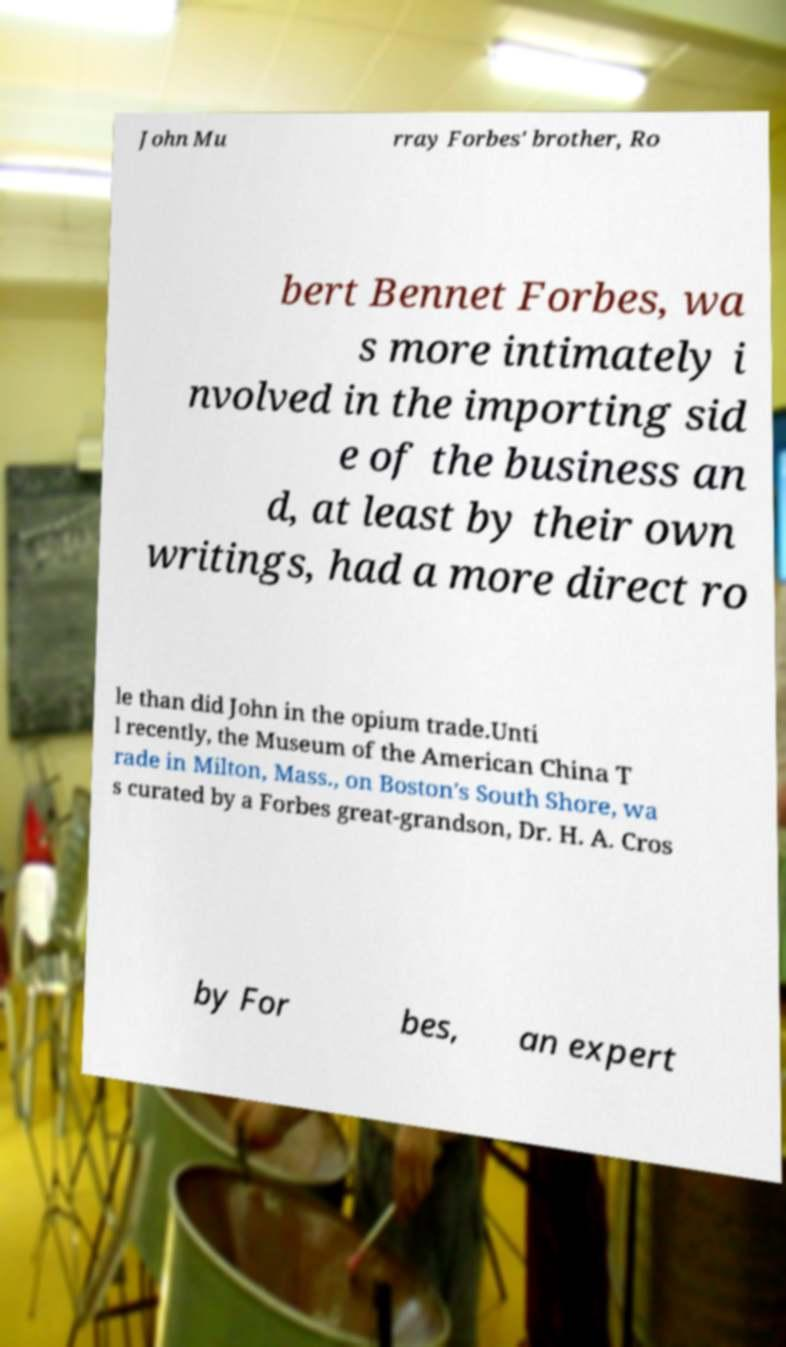What messages or text are displayed in this image? I need them in a readable, typed format. John Mu rray Forbes' brother, Ro bert Bennet Forbes, wa s more intimately i nvolved in the importing sid e of the business an d, at least by their own writings, had a more direct ro le than did John in the opium trade.Unti l recently, the Museum of the American China T rade in Milton, Mass., on Boston's South Shore, wa s curated by a Forbes great-grandson, Dr. H. A. Cros by For bes, an expert 